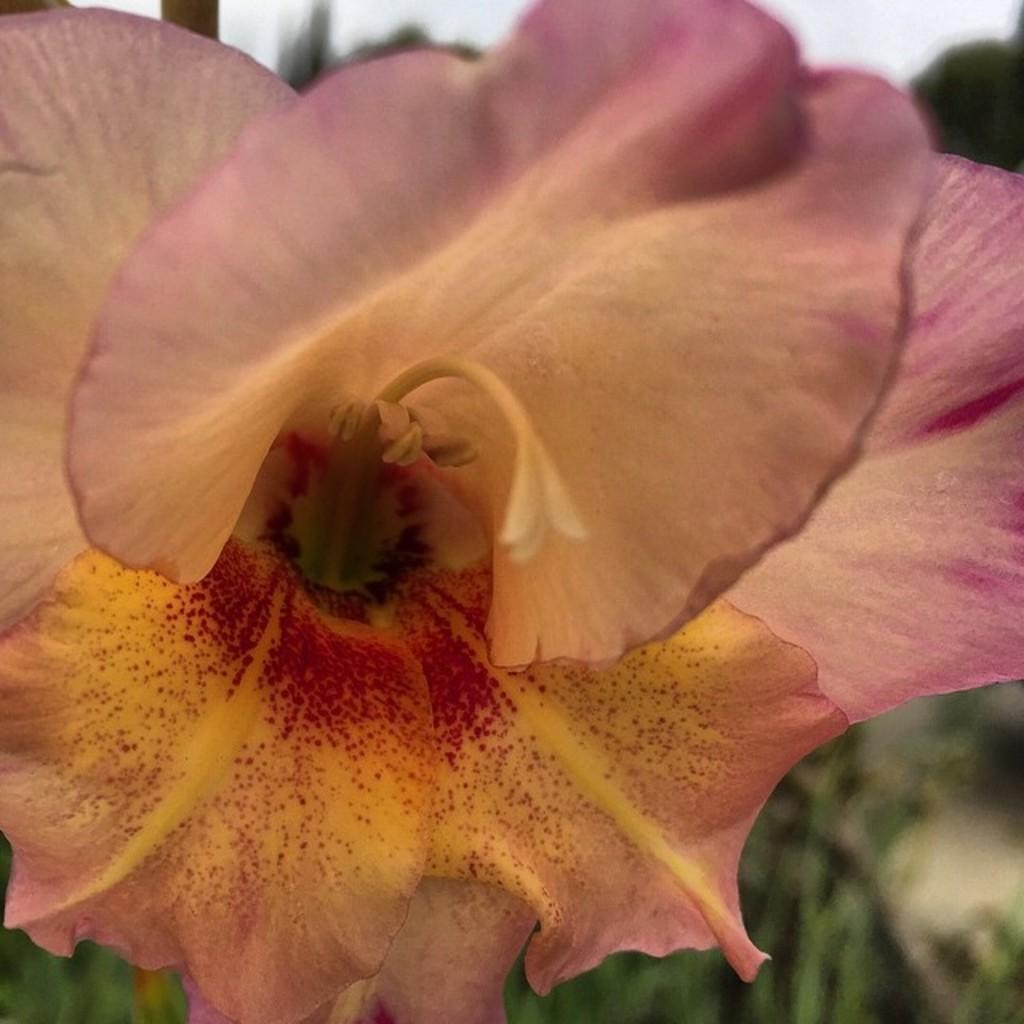What is the main subject of the picture? There is a flower in the picture. What can be seen in the background of the image? The sky is visible in the picture. How would you describe the background of the image? The background appears blurry. What type of lock can be seen securing the street in the image? There is no lock or street present in the image; it features a flower and a blurry background. 